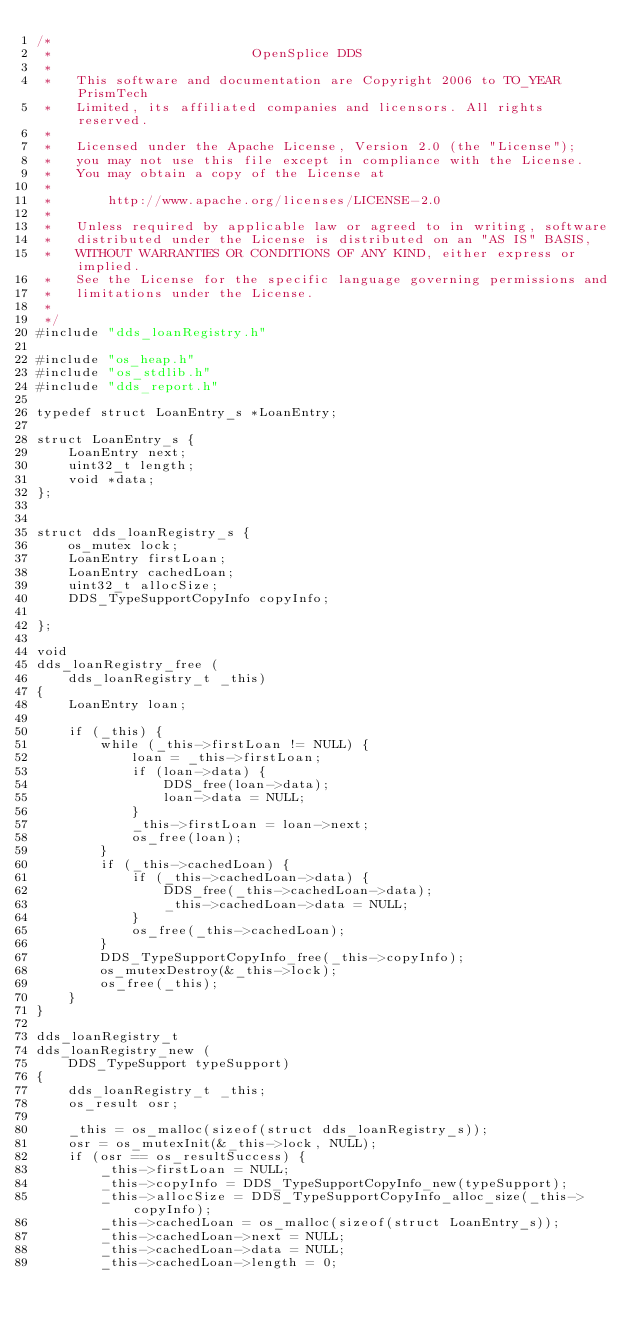<code> <loc_0><loc_0><loc_500><loc_500><_C_>/*
 *                         OpenSplice DDS
 *
 *   This software and documentation are Copyright 2006 to TO_YEAR PrismTech
 *   Limited, its affiliated companies and licensors. All rights reserved.
 *
 *   Licensed under the Apache License, Version 2.0 (the "License");
 *   you may not use this file except in compliance with the License.
 *   You may obtain a copy of the License at
 *
 *       http://www.apache.org/licenses/LICENSE-2.0
 *
 *   Unless required by applicable law or agreed to in writing, software
 *   distributed under the License is distributed on an "AS IS" BASIS,
 *   WITHOUT WARRANTIES OR CONDITIONS OF ANY KIND, either express or implied.
 *   See the License for the specific language governing permissions and
 *   limitations under the License.
 *
 */
#include "dds_loanRegistry.h"

#include "os_heap.h"
#include "os_stdlib.h"
#include "dds_report.h"

typedef struct LoanEntry_s *LoanEntry;

struct LoanEntry_s {
    LoanEntry next;
    uint32_t length;
    void *data;
};


struct dds_loanRegistry_s {
    os_mutex lock;
    LoanEntry firstLoan;
    LoanEntry cachedLoan;
    uint32_t allocSize;
    DDS_TypeSupportCopyInfo copyInfo;

};

void
dds_loanRegistry_free (
    dds_loanRegistry_t _this)
{
    LoanEntry loan;

    if (_this) {
        while (_this->firstLoan != NULL) {
            loan = _this->firstLoan;
            if (loan->data) {
                DDS_free(loan->data);
                loan->data = NULL;
            }
            _this->firstLoan = loan->next;
            os_free(loan);
        }
        if (_this->cachedLoan) {
            if (_this->cachedLoan->data) {
                DDS_free(_this->cachedLoan->data);
                _this->cachedLoan->data = NULL;
            }
            os_free(_this->cachedLoan);
        }
        DDS_TypeSupportCopyInfo_free(_this->copyInfo);
        os_mutexDestroy(&_this->lock);
        os_free(_this);
    }
}

dds_loanRegistry_t
dds_loanRegistry_new (
    DDS_TypeSupport typeSupport)
{
    dds_loanRegistry_t _this;
    os_result osr;

    _this = os_malloc(sizeof(struct dds_loanRegistry_s));
    osr = os_mutexInit(&_this->lock, NULL);
    if (osr == os_resultSuccess) {
        _this->firstLoan = NULL;
        _this->copyInfo = DDS_TypeSupportCopyInfo_new(typeSupport);
        _this->allocSize = DDS_TypeSupportCopyInfo_alloc_size(_this->copyInfo);
        _this->cachedLoan = os_malloc(sizeof(struct LoanEntry_s));
        _this->cachedLoan->next = NULL;
        _this->cachedLoan->data = NULL;
        _this->cachedLoan->length = 0;</code> 